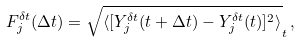<formula> <loc_0><loc_0><loc_500><loc_500>F _ { j } ^ { \delta t } ( \Delta t ) = \sqrt { \langle [ Y _ { j } ^ { \delta t } ( t + \Delta t ) - Y _ { j } ^ { \delta t } ( t ) ] ^ { 2 } \rangle } _ { t } \, ,</formula> 